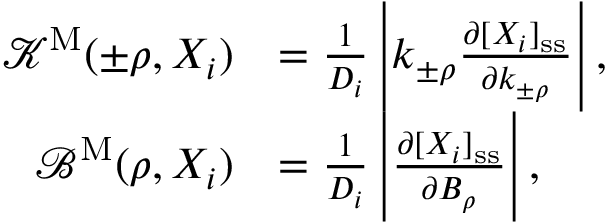Convert formula to latex. <formula><loc_0><loc_0><loc_500><loc_500>\begin{array} { r l } { { \mathcal { K } } ^ { M } ( \pm \rho , X _ { i } ) } & { = \frac { 1 } { D _ { i } } \left | k _ { \pm \rho } \frac { \partial [ X _ { i } ] _ { s s } } { \partial k _ { \pm \rho } } \right | , } \\ { { \mathcal { B } } ^ { M } ( \rho , X _ { i } ) } & { = \frac { 1 } { D _ { i } } \left | \frac { \partial [ X _ { i } ] _ { s s } } { \partial B _ { \rho } } \right | , } \end{array}</formula> 